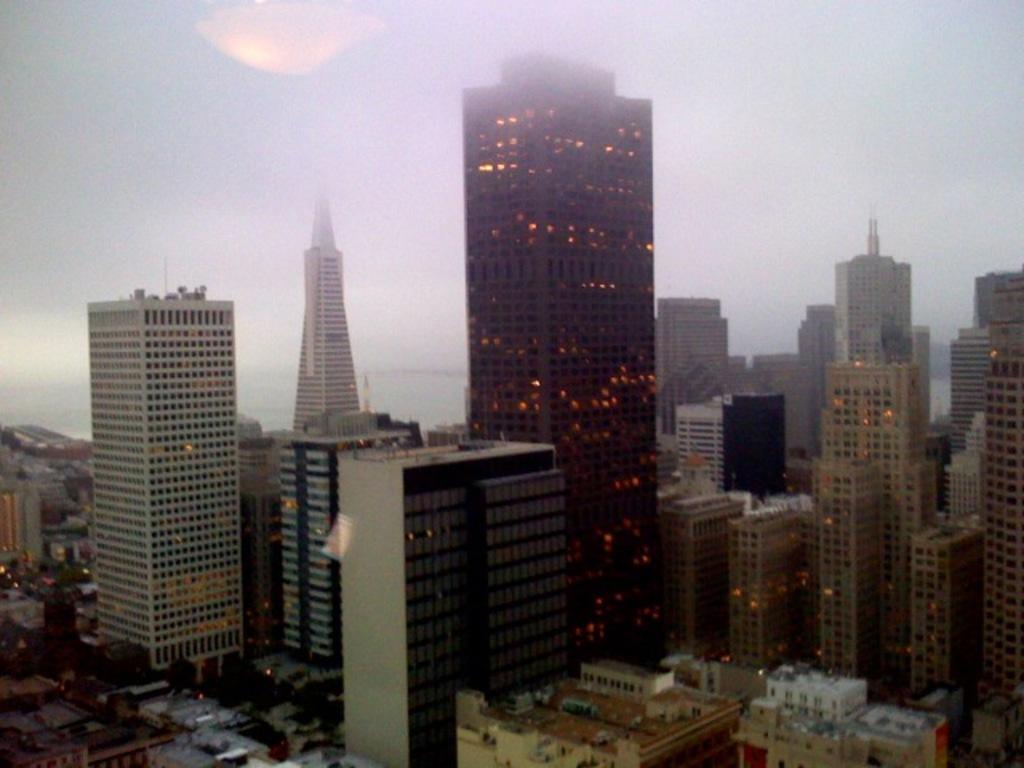In one or two sentences, can you explain what this image depicts? In this image I can see few buildings in white, cream and black color. I can also see few lights, trees and the sky is in white color. 